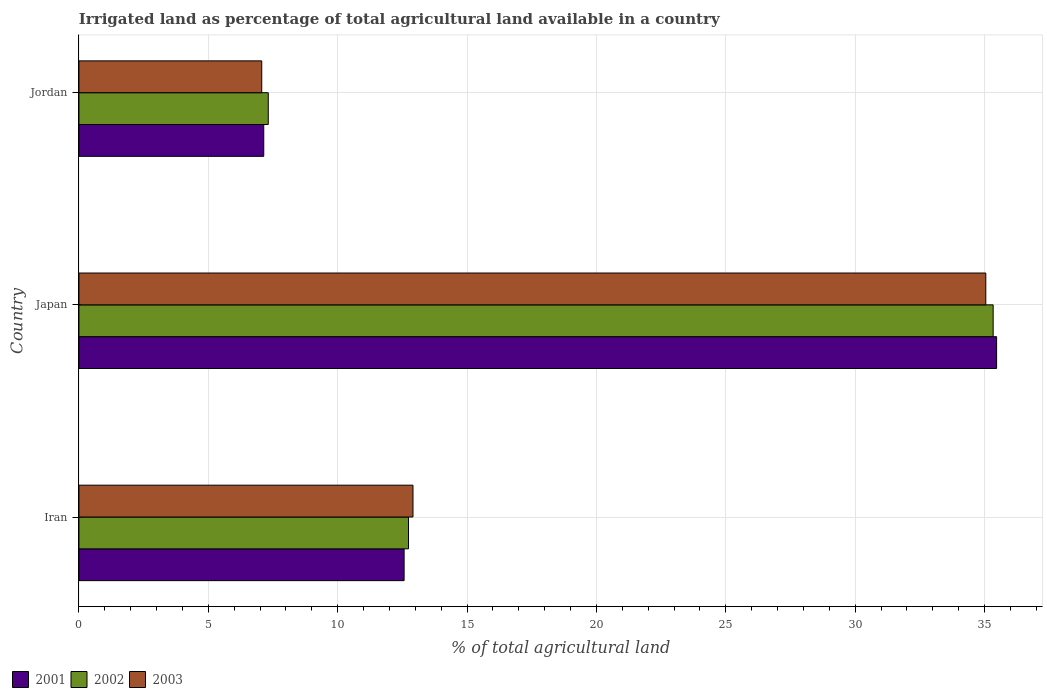How many different coloured bars are there?
Give a very brief answer. 3. How many groups of bars are there?
Ensure brevity in your answer.  3. Are the number of bars on each tick of the Y-axis equal?
Offer a very short reply. Yes. How many bars are there on the 2nd tick from the top?
Offer a very short reply. 3. What is the label of the 3rd group of bars from the top?
Offer a very short reply. Iran. In how many cases, is the number of bars for a given country not equal to the number of legend labels?
Provide a short and direct response. 0. What is the percentage of irrigated land in 2003 in Jordan?
Provide a short and direct response. 7.06. Across all countries, what is the maximum percentage of irrigated land in 2001?
Offer a very short reply. 35.47. Across all countries, what is the minimum percentage of irrigated land in 2002?
Your answer should be compact. 7.32. In which country was the percentage of irrigated land in 2002 minimum?
Offer a terse response. Jordan. What is the total percentage of irrigated land in 2003 in the graph?
Provide a short and direct response. 55.03. What is the difference between the percentage of irrigated land in 2003 in Iran and that in Jordan?
Your response must be concise. 5.85. What is the difference between the percentage of irrigated land in 2003 in Japan and the percentage of irrigated land in 2001 in Iran?
Provide a succinct answer. 22.48. What is the average percentage of irrigated land in 2003 per country?
Keep it short and to the point. 18.34. What is the difference between the percentage of irrigated land in 2002 and percentage of irrigated land in 2001 in Jordan?
Your response must be concise. 0.17. In how many countries, is the percentage of irrigated land in 2003 greater than 5 %?
Ensure brevity in your answer.  3. What is the ratio of the percentage of irrigated land in 2001 in Iran to that in Jordan?
Your answer should be very brief. 1.76. Is the difference between the percentage of irrigated land in 2002 in Iran and Jordan greater than the difference between the percentage of irrigated land in 2001 in Iran and Jordan?
Your answer should be very brief. No. What is the difference between the highest and the second highest percentage of irrigated land in 2003?
Your answer should be compact. 22.14. What is the difference between the highest and the lowest percentage of irrigated land in 2003?
Your response must be concise. 27.99. In how many countries, is the percentage of irrigated land in 2002 greater than the average percentage of irrigated land in 2002 taken over all countries?
Give a very brief answer. 1. Is the sum of the percentage of irrigated land in 2001 in Iran and Jordan greater than the maximum percentage of irrigated land in 2003 across all countries?
Your answer should be compact. No. What does the 1st bar from the bottom in Iran represents?
Your response must be concise. 2001. How many bars are there?
Ensure brevity in your answer.  9. What is the difference between two consecutive major ticks on the X-axis?
Keep it short and to the point. 5. Does the graph contain grids?
Provide a succinct answer. Yes. How are the legend labels stacked?
Ensure brevity in your answer.  Horizontal. What is the title of the graph?
Your response must be concise. Irrigated land as percentage of total agricultural land available in a country. Does "1983" appear as one of the legend labels in the graph?
Provide a short and direct response. No. What is the label or title of the X-axis?
Your answer should be very brief. % of total agricultural land. What is the % of total agricultural land in 2001 in Iran?
Your answer should be compact. 12.57. What is the % of total agricultural land in 2002 in Iran?
Offer a very short reply. 12.74. What is the % of total agricultural land of 2003 in Iran?
Offer a terse response. 12.91. What is the % of total agricultural land of 2001 in Japan?
Provide a succinct answer. 35.47. What is the % of total agricultural land of 2002 in Japan?
Your answer should be very brief. 35.33. What is the % of total agricultural land of 2003 in Japan?
Your answer should be compact. 35.05. What is the % of total agricultural land of 2001 in Jordan?
Your answer should be very brief. 7.14. What is the % of total agricultural land in 2002 in Jordan?
Your answer should be compact. 7.32. What is the % of total agricultural land of 2003 in Jordan?
Provide a succinct answer. 7.06. Across all countries, what is the maximum % of total agricultural land of 2001?
Your response must be concise. 35.47. Across all countries, what is the maximum % of total agricultural land of 2002?
Your answer should be compact. 35.33. Across all countries, what is the maximum % of total agricultural land of 2003?
Offer a terse response. 35.05. Across all countries, what is the minimum % of total agricultural land of 2001?
Ensure brevity in your answer.  7.14. Across all countries, what is the minimum % of total agricultural land of 2002?
Ensure brevity in your answer.  7.32. Across all countries, what is the minimum % of total agricultural land in 2003?
Make the answer very short. 7.06. What is the total % of total agricultural land of 2001 in the graph?
Your answer should be compact. 55.18. What is the total % of total agricultural land in 2002 in the graph?
Ensure brevity in your answer.  55.39. What is the total % of total agricultural land of 2003 in the graph?
Provide a succinct answer. 55.03. What is the difference between the % of total agricultural land of 2001 in Iran and that in Japan?
Offer a very short reply. -22.9. What is the difference between the % of total agricultural land in 2002 in Iran and that in Japan?
Ensure brevity in your answer.  -22.6. What is the difference between the % of total agricultural land in 2003 in Iran and that in Japan?
Offer a terse response. -22.14. What is the difference between the % of total agricultural land of 2001 in Iran and that in Jordan?
Your answer should be very brief. 5.42. What is the difference between the % of total agricultural land in 2002 in Iran and that in Jordan?
Ensure brevity in your answer.  5.42. What is the difference between the % of total agricultural land in 2003 in Iran and that in Jordan?
Offer a terse response. 5.85. What is the difference between the % of total agricultural land in 2001 in Japan and that in Jordan?
Offer a terse response. 28.33. What is the difference between the % of total agricultural land of 2002 in Japan and that in Jordan?
Ensure brevity in your answer.  28.02. What is the difference between the % of total agricultural land in 2003 in Japan and that in Jordan?
Make the answer very short. 27.99. What is the difference between the % of total agricultural land of 2001 in Iran and the % of total agricultural land of 2002 in Japan?
Provide a short and direct response. -22.77. What is the difference between the % of total agricultural land of 2001 in Iran and the % of total agricultural land of 2003 in Japan?
Provide a short and direct response. -22.48. What is the difference between the % of total agricultural land of 2002 in Iran and the % of total agricultural land of 2003 in Japan?
Your response must be concise. -22.31. What is the difference between the % of total agricultural land in 2001 in Iran and the % of total agricultural land in 2002 in Jordan?
Keep it short and to the point. 5.25. What is the difference between the % of total agricultural land in 2001 in Iran and the % of total agricultural land in 2003 in Jordan?
Offer a very short reply. 5.5. What is the difference between the % of total agricultural land of 2002 in Iran and the % of total agricultural land of 2003 in Jordan?
Make the answer very short. 5.67. What is the difference between the % of total agricultural land of 2001 in Japan and the % of total agricultural land of 2002 in Jordan?
Offer a very short reply. 28.15. What is the difference between the % of total agricultural land in 2001 in Japan and the % of total agricultural land in 2003 in Jordan?
Make the answer very short. 28.4. What is the difference between the % of total agricultural land of 2002 in Japan and the % of total agricultural land of 2003 in Jordan?
Your response must be concise. 28.27. What is the average % of total agricultural land of 2001 per country?
Your answer should be very brief. 18.39. What is the average % of total agricultural land in 2002 per country?
Make the answer very short. 18.46. What is the average % of total agricultural land in 2003 per country?
Make the answer very short. 18.34. What is the difference between the % of total agricultural land of 2001 and % of total agricultural land of 2002 in Iran?
Make the answer very short. -0.17. What is the difference between the % of total agricultural land of 2001 and % of total agricultural land of 2003 in Iran?
Your answer should be very brief. -0.34. What is the difference between the % of total agricultural land of 2002 and % of total agricultural land of 2003 in Iran?
Give a very brief answer. -0.17. What is the difference between the % of total agricultural land in 2001 and % of total agricultural land in 2002 in Japan?
Make the answer very short. 0.13. What is the difference between the % of total agricultural land of 2001 and % of total agricultural land of 2003 in Japan?
Make the answer very short. 0.42. What is the difference between the % of total agricultural land of 2002 and % of total agricultural land of 2003 in Japan?
Offer a very short reply. 0.28. What is the difference between the % of total agricultural land of 2001 and % of total agricultural land of 2002 in Jordan?
Provide a succinct answer. -0.17. What is the difference between the % of total agricultural land of 2001 and % of total agricultural land of 2003 in Jordan?
Offer a terse response. 0.08. What is the difference between the % of total agricultural land of 2002 and % of total agricultural land of 2003 in Jordan?
Offer a terse response. 0.25. What is the ratio of the % of total agricultural land in 2001 in Iran to that in Japan?
Your response must be concise. 0.35. What is the ratio of the % of total agricultural land of 2002 in Iran to that in Japan?
Your response must be concise. 0.36. What is the ratio of the % of total agricultural land in 2003 in Iran to that in Japan?
Offer a very short reply. 0.37. What is the ratio of the % of total agricultural land in 2001 in Iran to that in Jordan?
Provide a succinct answer. 1.76. What is the ratio of the % of total agricultural land in 2002 in Iran to that in Jordan?
Your answer should be compact. 1.74. What is the ratio of the % of total agricultural land of 2003 in Iran to that in Jordan?
Your answer should be very brief. 1.83. What is the ratio of the % of total agricultural land in 2001 in Japan to that in Jordan?
Offer a terse response. 4.97. What is the ratio of the % of total agricultural land in 2002 in Japan to that in Jordan?
Provide a succinct answer. 4.83. What is the ratio of the % of total agricultural land of 2003 in Japan to that in Jordan?
Keep it short and to the point. 4.96. What is the difference between the highest and the second highest % of total agricultural land in 2001?
Provide a succinct answer. 22.9. What is the difference between the highest and the second highest % of total agricultural land in 2002?
Give a very brief answer. 22.6. What is the difference between the highest and the second highest % of total agricultural land of 2003?
Ensure brevity in your answer.  22.14. What is the difference between the highest and the lowest % of total agricultural land in 2001?
Your answer should be very brief. 28.33. What is the difference between the highest and the lowest % of total agricultural land in 2002?
Provide a short and direct response. 28.02. What is the difference between the highest and the lowest % of total agricultural land of 2003?
Provide a succinct answer. 27.99. 